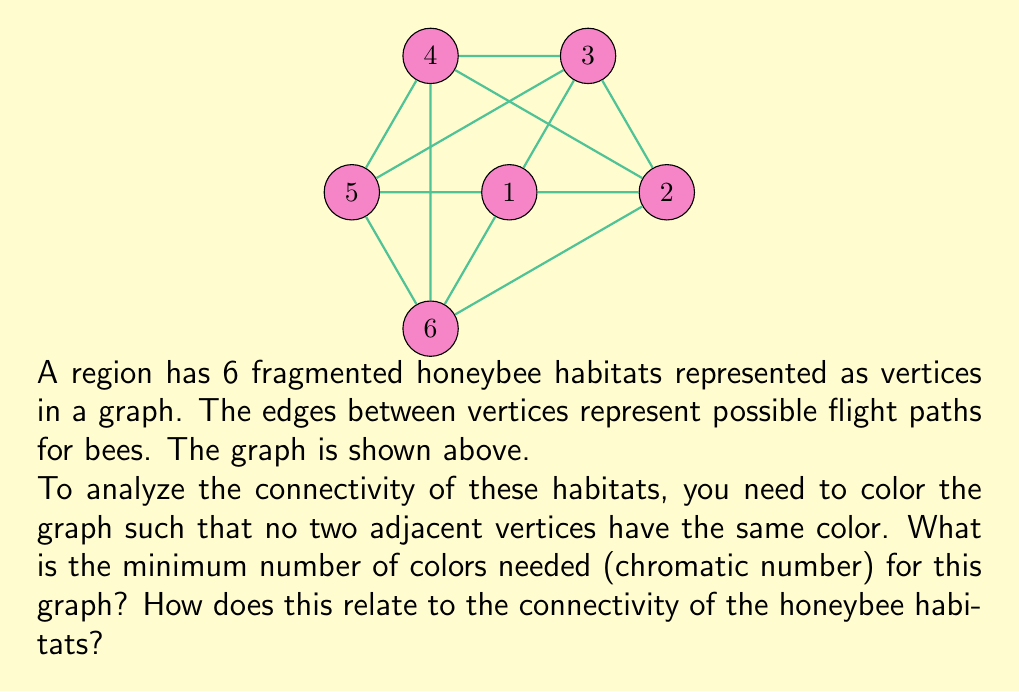Show me your answer to this math problem. To solve this problem, we'll use the concept of graph coloring and determine the chromatic number:

1) First, observe that the graph is highly connected, forming a complete graph K₃ (vertices 1, 3, 5) inscribed in another K₃ (vertices 2, 4, 6).

2) In any proper coloring, each vertex of a triangle (K₃) must have a different color. So, we need at least 3 colors.

3) Let's attempt to color the graph with 3 colors:
   - Color vertices 1, 3, 5 with colors Red, Blue, Green respectively.
   - For vertex 2: It's adjacent to 1 (Red) and 3 (Blue), so it must be Green.
   - For vertex 4: It's adjacent to 3 (Blue) and 5 (Green), so it must be Red.
   - For vertex 6: It's adjacent to 5 (Green) and 1 (Red), so it must be Blue.

4) This coloring works, using exactly 3 colors, and no two adjacent vertices have the same color.

5) Therefore, the chromatic number of this graph is 3.

Relation to honeybee habitats:
- The chromatic number represents the minimum number of distinct "zones" or "time slots" needed for bees to move between all habitats without interference.
- A lower chromatic number (3 in this case) indicates high connectivity, as bees can efficiently navigate between all habitats with minimal partitioning.
- This information can guide policy decisions on habitat management and conservation efforts to maintain or improve connectivity for honeybee populations.
Answer: Chromatic number: 3 